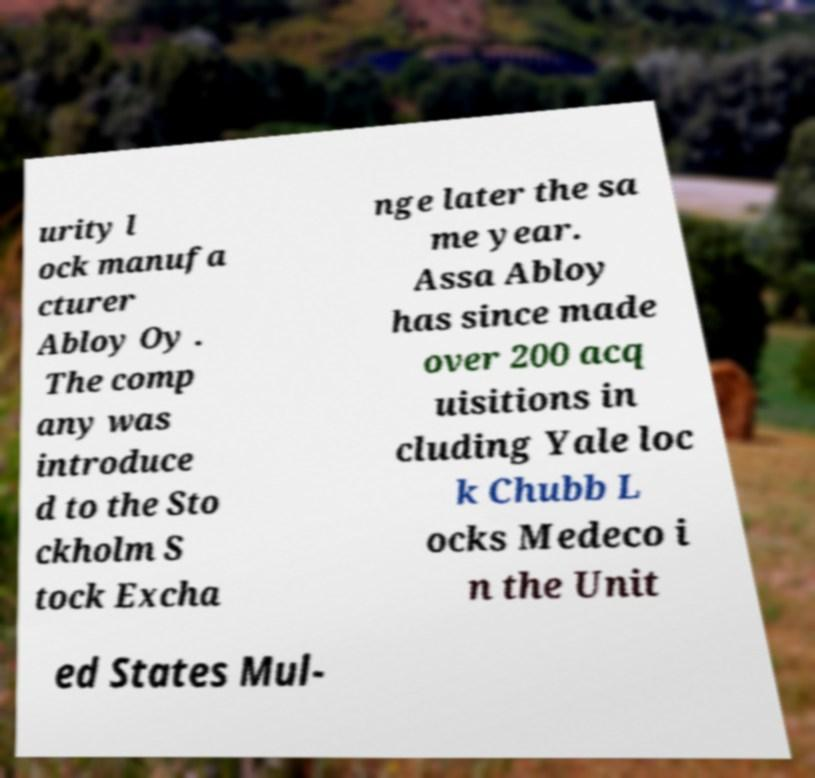For documentation purposes, I need the text within this image transcribed. Could you provide that? urity l ock manufa cturer Abloy Oy . The comp any was introduce d to the Sto ckholm S tock Excha nge later the sa me year. Assa Abloy has since made over 200 acq uisitions in cluding Yale loc k Chubb L ocks Medeco i n the Unit ed States Mul- 